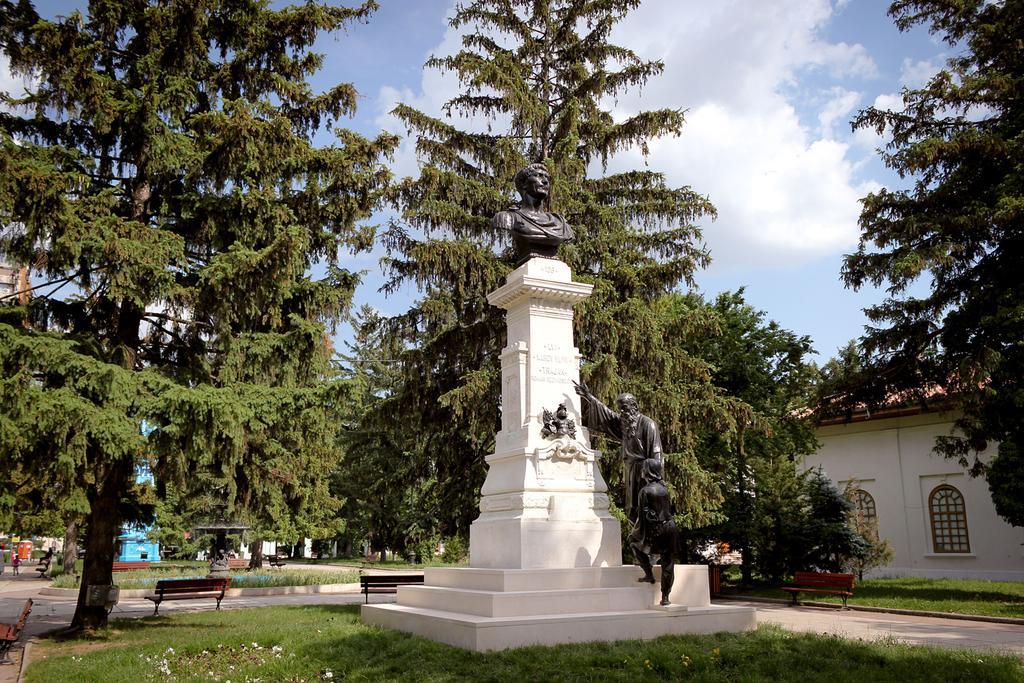Could you give a brief overview of what you see in this image? In the foreground of the picture we can see trees, benches, plants, flower, path and a sculpture. In the middle of the picture there are buildings, sculpture, plants, benches, trees and other objects. At the top it is sky. 